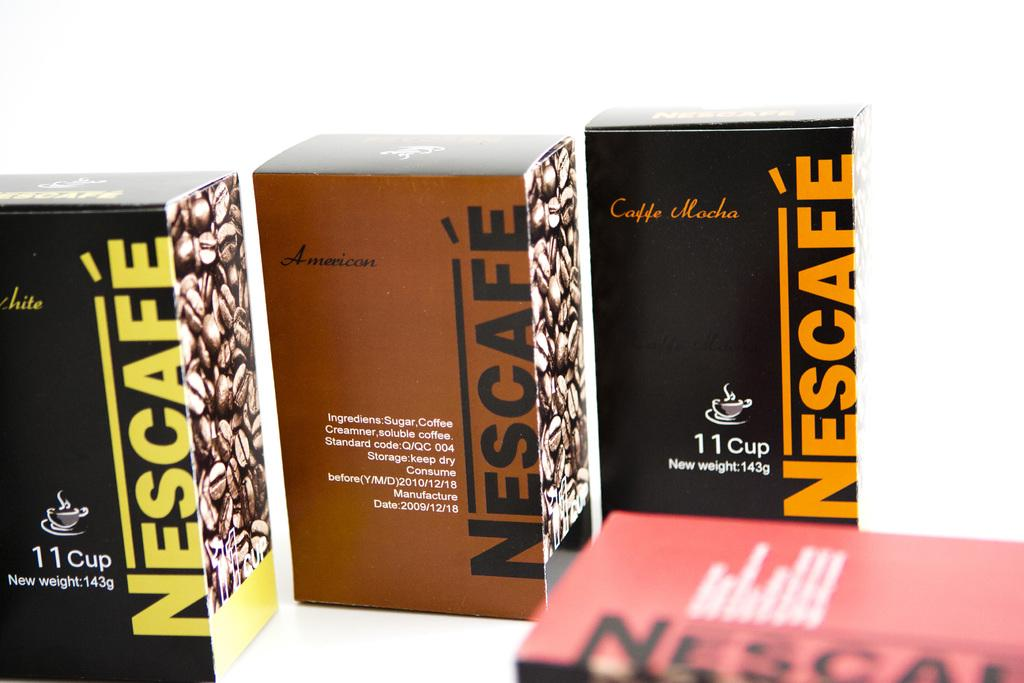What objects are present in the image? There are boxes in the image. What can be seen on the boxes? The boxes have text and images on them. What is the color of the background in the image? The background of the image is white. What type of fuel is being stored in the boxes in the image? There is no indication of fuel or any type of storage in the image; it only features boxes with text and images. Can you see any straw in the image? There is no straw present in the image. 